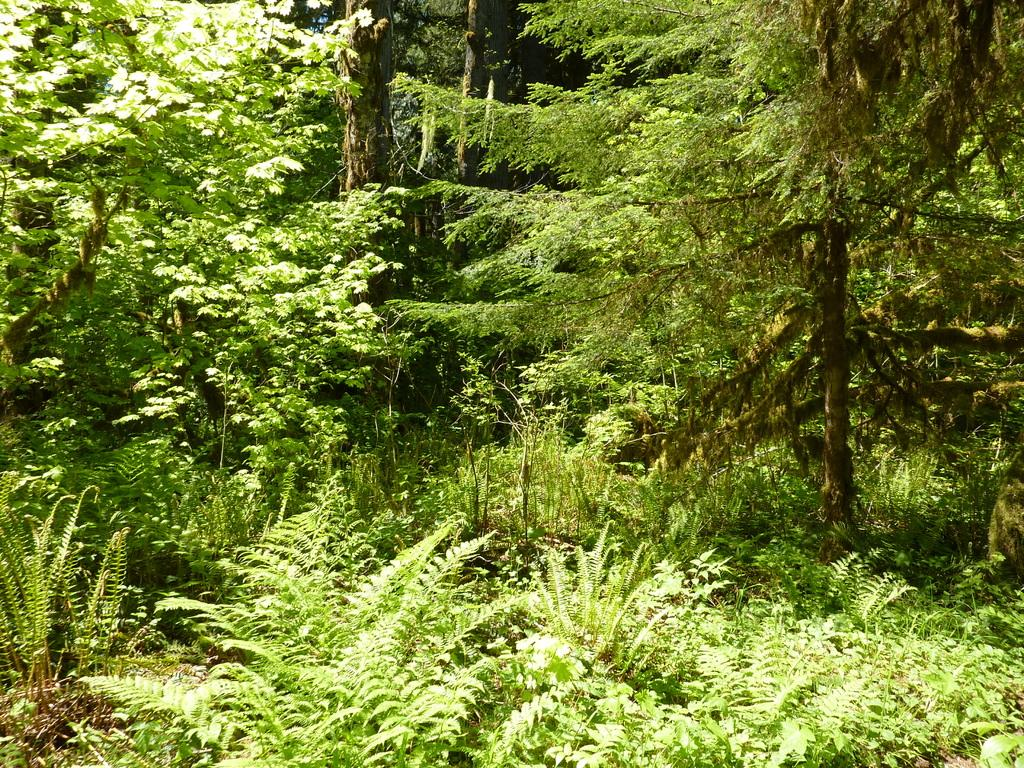What celestial bodies can be seen in the image? There are planets visible in the image. What type of vegetation is present in the image? There are trees in the image. What type of bridge can be seen connecting the planets in the image? There is no bridge connecting the planets in the image, as the planets are celestial bodies in space and not connected by any physical structure. 